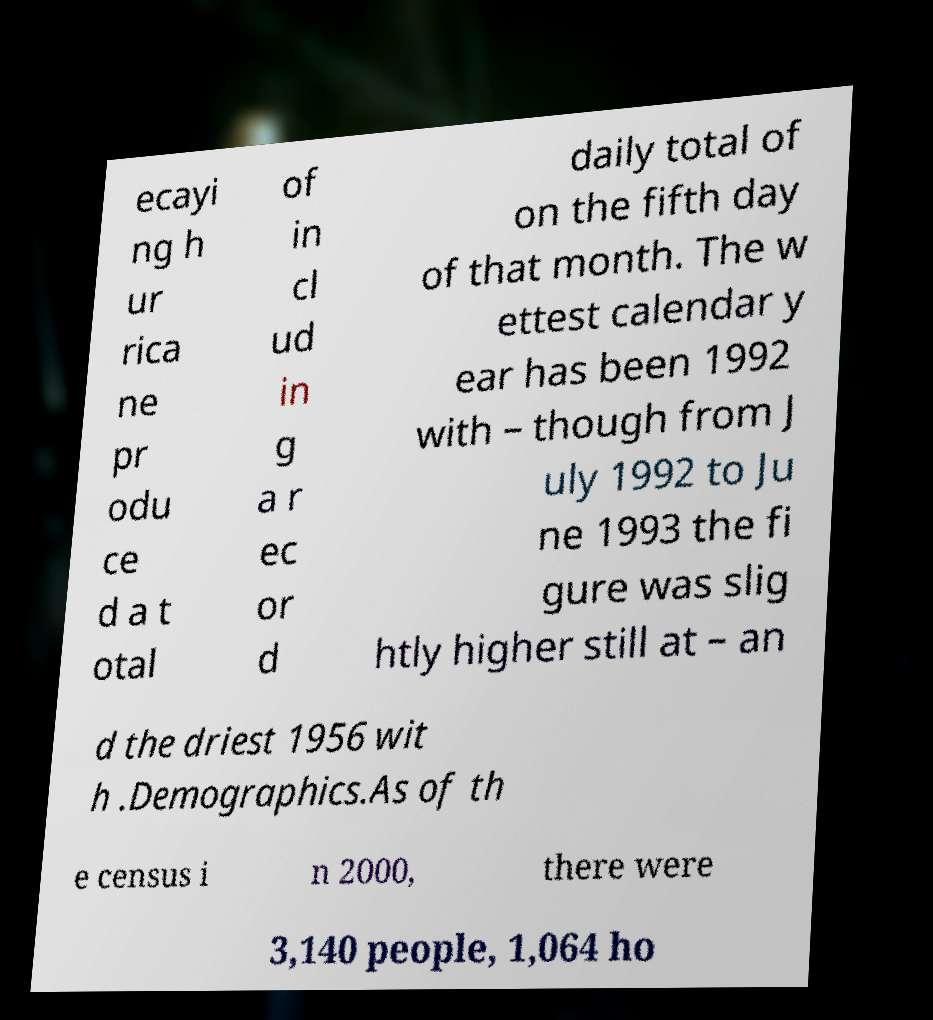Please identify and transcribe the text found in this image. ecayi ng h ur rica ne pr odu ce d a t otal of in cl ud in g a r ec or d daily total of on the fifth day of that month. The w ettest calendar y ear has been 1992 with – though from J uly 1992 to Ju ne 1993 the fi gure was slig htly higher still at – an d the driest 1956 wit h .Demographics.As of th e census i n 2000, there were 3,140 people, 1,064 ho 